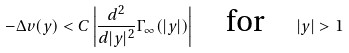<formula> <loc_0><loc_0><loc_500><loc_500>- \Delta v ( y ) < C \left | \frac { d ^ { 2 } } { d | y | ^ { 2 } } \Gamma _ { \infty } ( | y | ) \right | \quad \text {for} \quad | y | > 1</formula> 